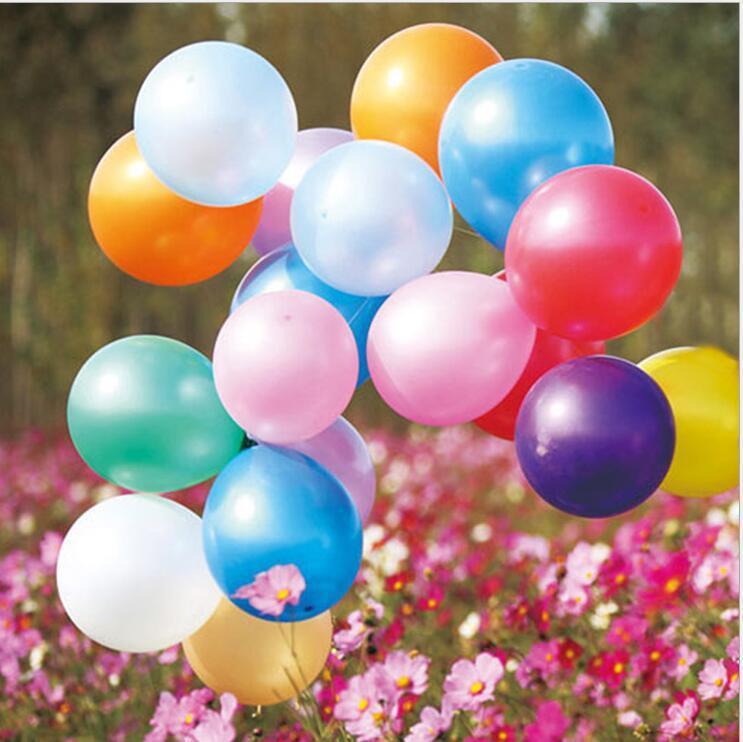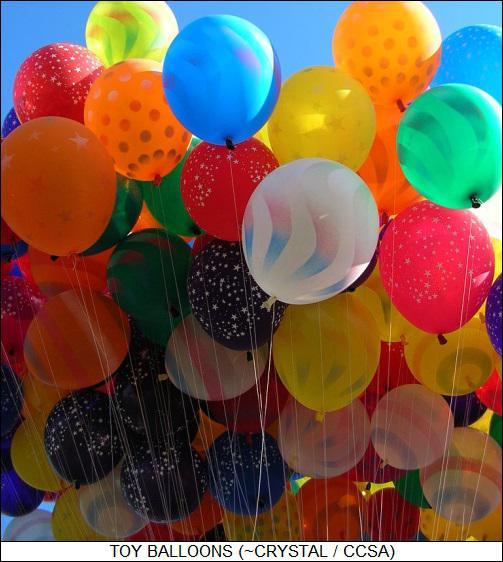The first image is the image on the left, the second image is the image on the right. Evaluate the accuracy of this statement regarding the images: "One of the images shows a clown wearing a hat.". Is it true? Answer yes or no. No. 